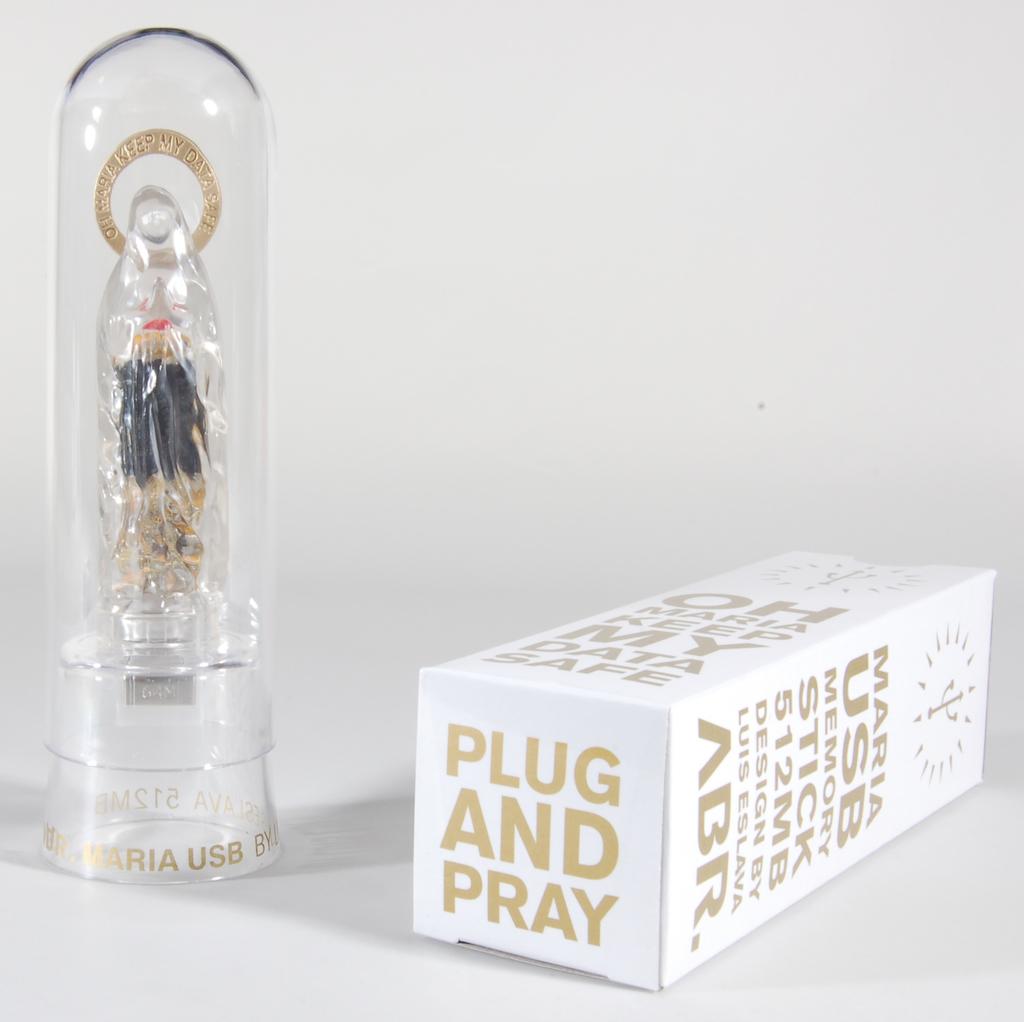What color is the letters?
Your response must be concise. Gold. What is written on the bottom of the box?
Provide a succinct answer. Plug and pray. 